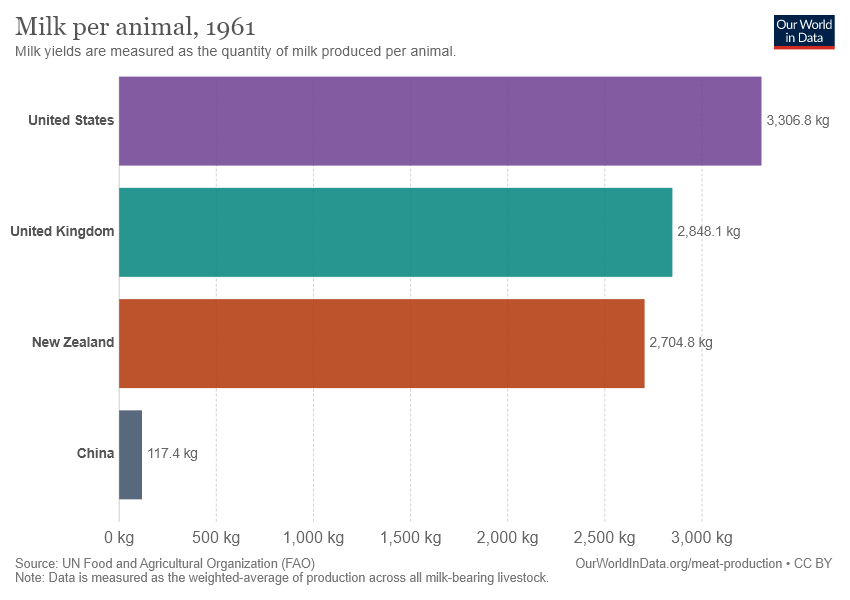Outline some significant characteristics in this image. According to recent data, China has the lowest milk production per animal among all countries. The average value of UK and US is 3077.45. 